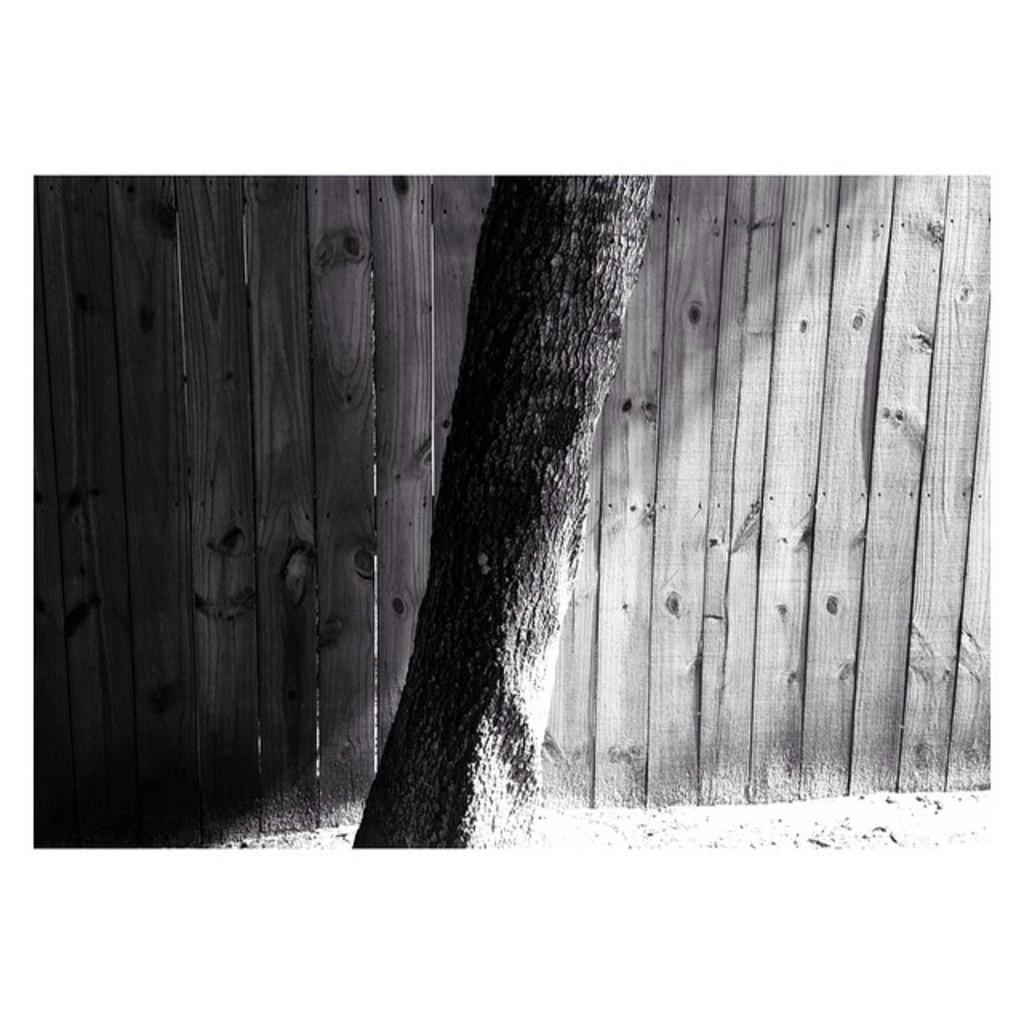What is the main subject in the foreground of the image? There is a tree trunk in the foreground of the image. What can be seen in the background of the image? There is a wooden wall in the background of the image. How many buckets are hanging on the tree trunk in the image? There are no buckets present in the image; it only features a tree trunk and a wooden wall. 